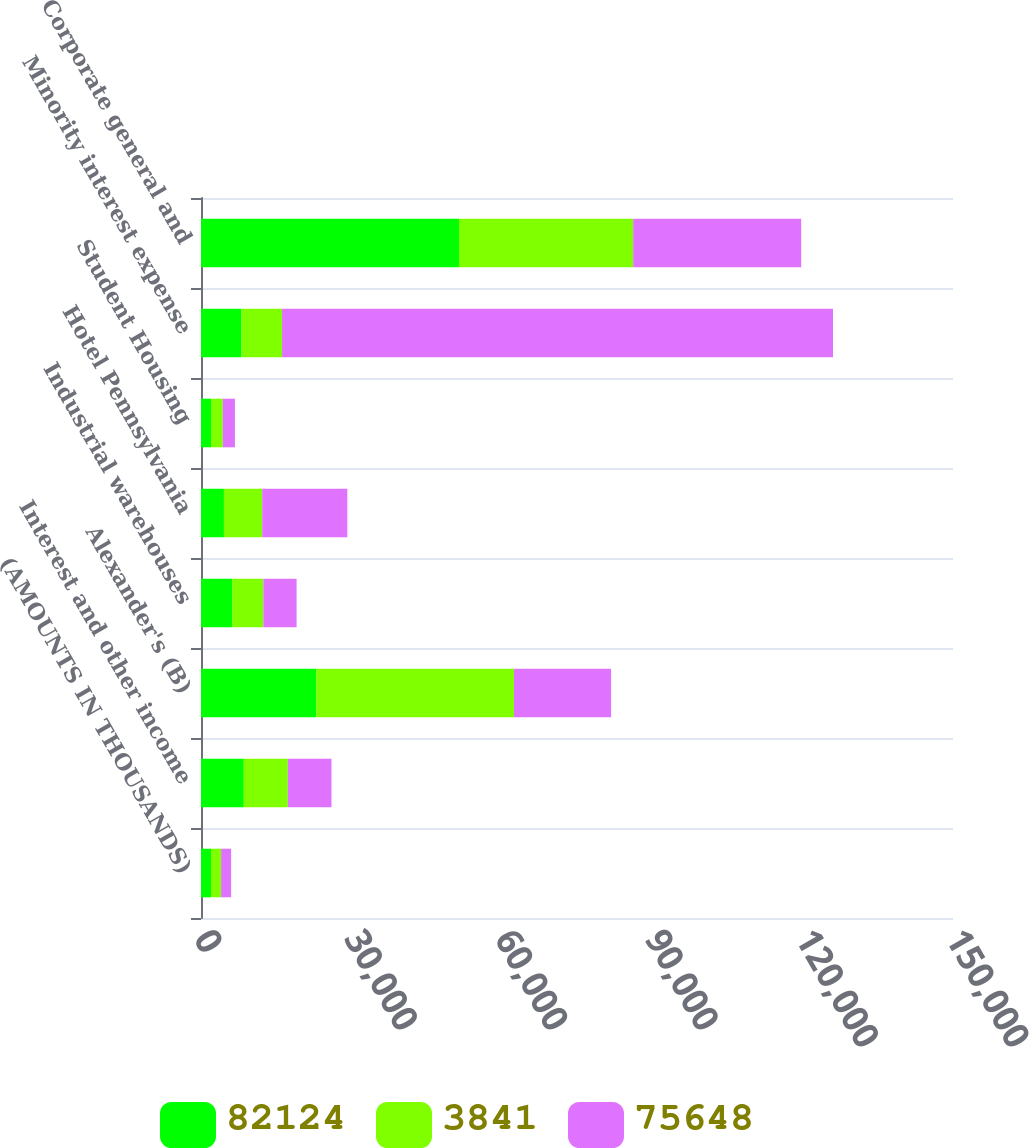Convert chart. <chart><loc_0><loc_0><loc_500><loc_500><stacked_bar_chart><ecel><fcel>(AMOUNTS IN THOUSANDS)<fcel>Interest and other income<fcel>Alexander's (B)<fcel>Industrial warehouses<fcel>Hotel Pennsylvania<fcel>Student Housing<fcel>Minority interest expense<fcel>Corporate general and<nl><fcel>82124<fcel>2003<fcel>8532<fcel>23001<fcel>6208<fcel>4573<fcel>2000<fcel>8084<fcel>51461<nl><fcel>3841<fcel>2002<fcel>8795<fcel>39436<fcel>6223<fcel>7636<fcel>2340<fcel>8084<fcel>34743<nl><fcel>75648<fcel>2001<fcel>8700<fcel>19362<fcel>6639<fcel>16978<fcel>2428<fcel>109897<fcel>33515<nl></chart> 